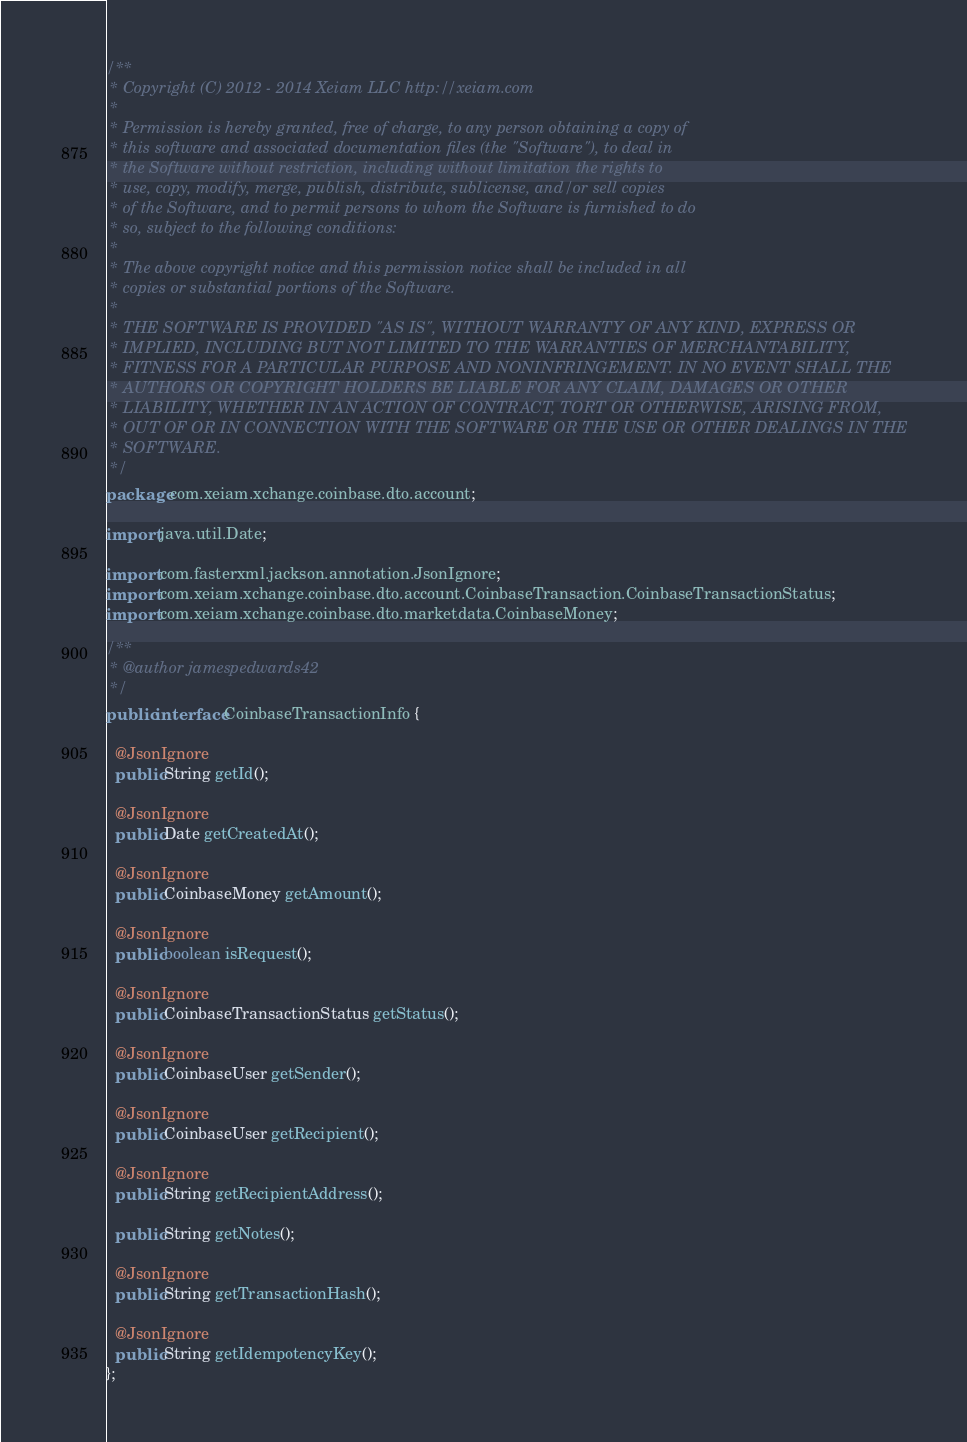Convert code to text. <code><loc_0><loc_0><loc_500><loc_500><_Java_>/**
 * Copyright (C) 2012 - 2014 Xeiam LLC http://xeiam.com
 *
 * Permission is hereby granted, free of charge, to any person obtaining a copy of
 * this software and associated documentation files (the "Software"), to deal in
 * the Software without restriction, including without limitation the rights to
 * use, copy, modify, merge, publish, distribute, sublicense, and/or sell copies
 * of the Software, and to permit persons to whom the Software is furnished to do
 * so, subject to the following conditions:
 *
 * The above copyright notice and this permission notice shall be included in all
 * copies or substantial portions of the Software.
 *
 * THE SOFTWARE IS PROVIDED "AS IS", WITHOUT WARRANTY OF ANY KIND, EXPRESS OR
 * IMPLIED, INCLUDING BUT NOT LIMITED TO THE WARRANTIES OF MERCHANTABILITY,
 * FITNESS FOR A PARTICULAR PURPOSE AND NONINFRINGEMENT. IN NO EVENT SHALL THE
 * AUTHORS OR COPYRIGHT HOLDERS BE LIABLE FOR ANY CLAIM, DAMAGES OR OTHER
 * LIABILITY, WHETHER IN AN ACTION OF CONTRACT, TORT OR OTHERWISE, ARISING FROM,
 * OUT OF OR IN CONNECTION WITH THE SOFTWARE OR THE USE OR OTHER DEALINGS IN THE
 * SOFTWARE.
 */
package com.xeiam.xchange.coinbase.dto.account;

import java.util.Date;

import com.fasterxml.jackson.annotation.JsonIgnore;
import com.xeiam.xchange.coinbase.dto.account.CoinbaseTransaction.CoinbaseTransactionStatus;
import com.xeiam.xchange.coinbase.dto.marketdata.CoinbaseMoney;

/**
 * @author jamespedwards42
 */
public interface CoinbaseTransactionInfo {

  @JsonIgnore
  public String getId();

  @JsonIgnore
  public Date getCreatedAt();

  @JsonIgnore
  public CoinbaseMoney getAmount();

  @JsonIgnore
  public boolean isRequest();

  @JsonIgnore
  public CoinbaseTransactionStatus getStatus();

  @JsonIgnore
  public CoinbaseUser getSender();

  @JsonIgnore
  public CoinbaseUser getRecipient();

  @JsonIgnore
  public String getRecipientAddress();

  public String getNotes();

  @JsonIgnore
  public String getTransactionHash();

  @JsonIgnore
  public String getIdempotencyKey();
};
</code> 